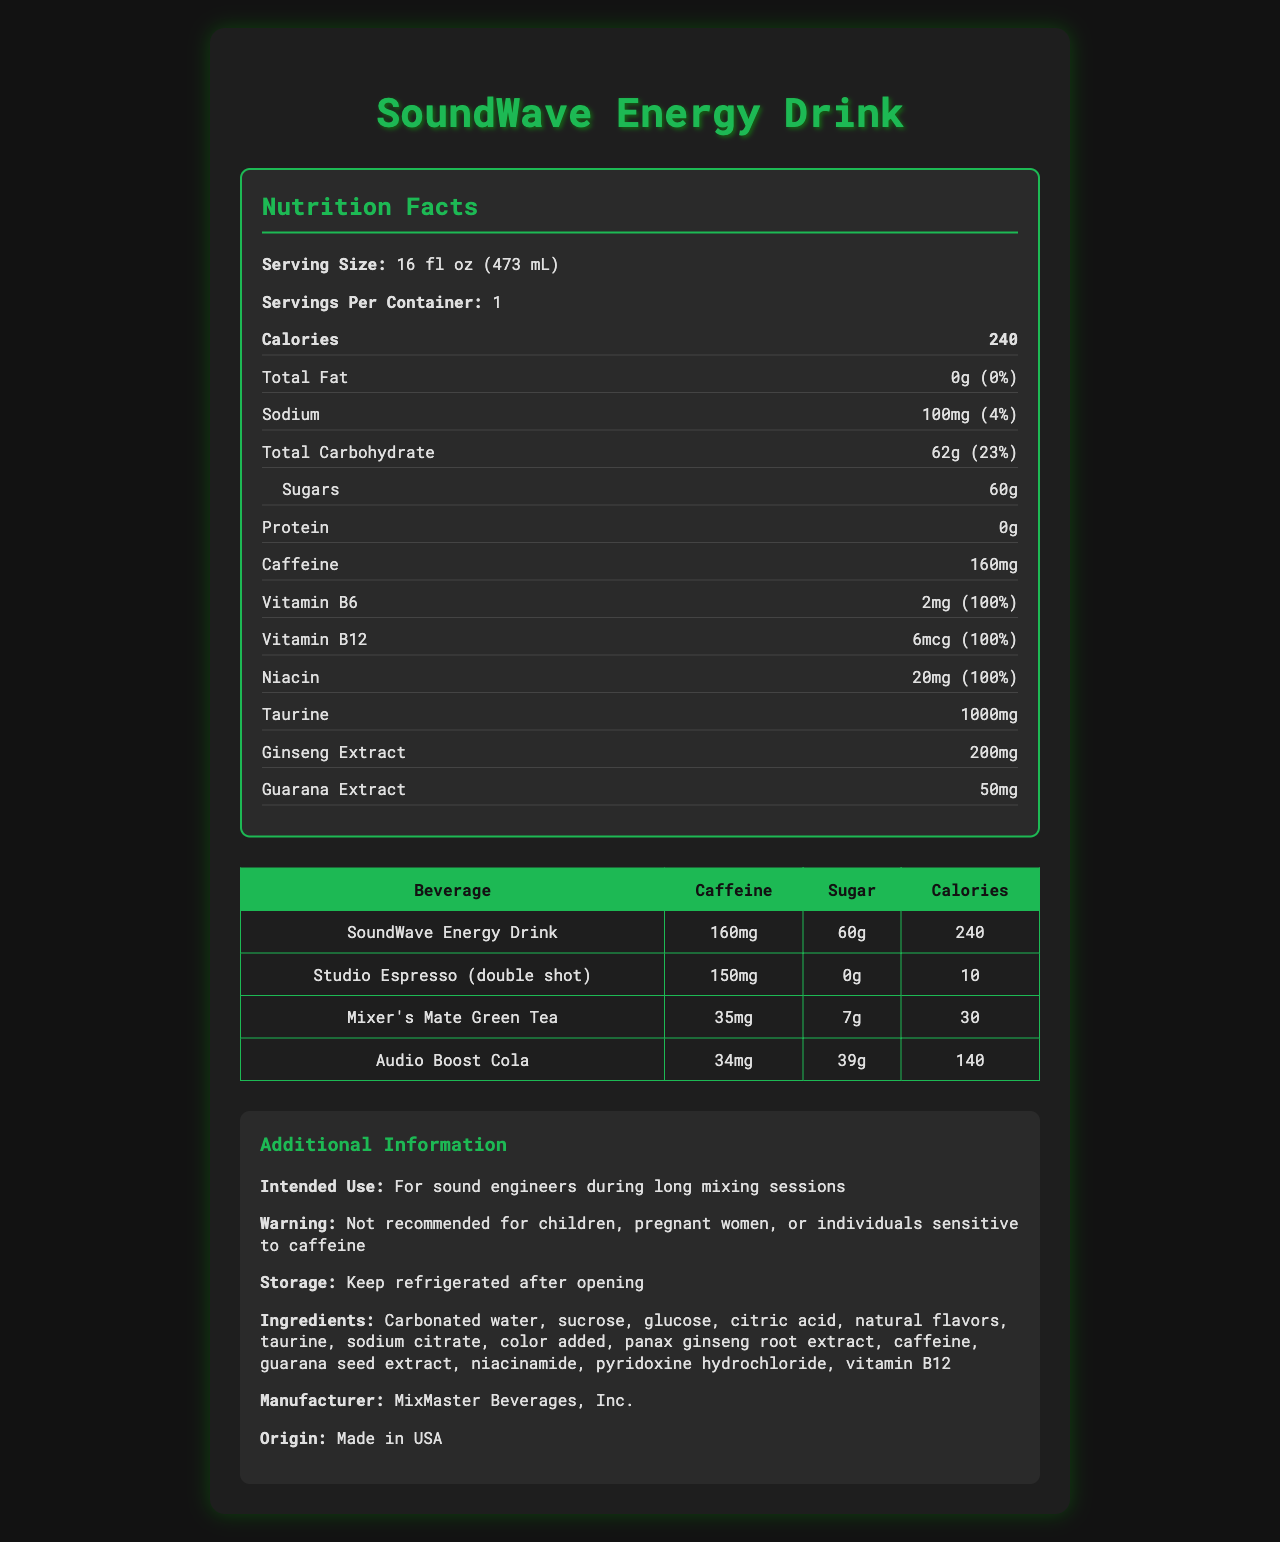what is the serving size of SoundWave Energy Drink? The serving size mentioned at the beginning of the Nutrition Facts section is "16 fl oz (473 mL)."
Answer: 16 fl oz (473 mL) how many calories are in a serving of SoundWave Energy Drink? The document lists the calories under the Nutrition Facts, showing "240" as the calorie amount.
Answer: 240 what is the amount of caffeine in a serving of SoundWave Energy Drink? Under the Nutrition Facts, it specifies the caffeine content as "160mg."
Answer: 160mg what vitamin has 100% daily value in SoundWave Energy Drink? The label lists Vitamin B6 (2mg), Vitamin B12 (6mcg), and Niacin (20mg) all having a daily value of 100%.
Answer: Vitamin B6, Vitamin B12, Niacin how much sodium is in a serving of SoundWave Energy Drink? The Nutrition Facts section shows sodium with an amount of "100mg."
Answer: 100mg which beverage has the highest caffeine content?  
A. SoundWave Energy Drink  
B. Studio Espresso (double shot)  
C. Mixer’s Mate Green Tea  
D. Audio Boost Cola The comparison table lists SoundWave Energy Drink with 160mg of caffeine, higher than the other beverages listed (Studio Espresso with 150mg, Mixer’s Mate Green Tea with 35mg, and Audio Boost Cola with 34mg).
Answer: A. SoundWave Energy Drink which beverage has the lowest calorie count?  
I. SoundWave Energy Drink  
II. Studio Espresso (double shot)  
III. Mixer’s Mate Green Tea  
IV. Audio Boost Cola Studio Espresso (double shot) has the lowest calorie count at 10 calories compared to SoundWave Energy Drink (240), Mixer’s Mate Green Tea (30), and Audio Boost Cola (140).
Answer: II. Studio Espresso (double shot) is there any protein in SoundWave Energy Drink? The Nutrition Facts section lists "0g" for protein, indicating no protein content.
Answer: No summarize the main idea of the document. The document aims to provide comprehensive nutritional and product information for SoundWave Energy Drink, highlighting its suitability for sound engineers during long mixing sessions and comparing its nutrient content with other common caffeinated beverages.
Answer: The document is a detailed Nutrition Facts Label for SoundWave Energy Drink, providing information on its serving size, calorie count, various nutrients, and ingredients. Additionally, it includes a comparison table with other caffeinated beverages and provides additional product information like intended use, warnings, storage instructions, manufacturer, and origin. which beverage has the highest sugar content in the comparison? According to the comparison table, SoundWave Energy Drink has the highest sugar content at 60g compared to the other beverages listed.
Answer: SoundWave Energy Drink how much of Vitamin B6 does SoundWave Energy Drink contain? The Nutrition Facts section shows Vitamin B6 with an amount of "2mg."
Answer: 2mg can children consume SoundWave Energy Drink? The additional information section provides a warning that states it is not recommended for children, pregnant women, or individuals sensitive to caffeine.
Answer: No what is the manufacturer of SoundWave Energy Drink? The additional information section lists the manufacturer as "MixMaster Beverages, Inc."
Answer: MixMaster Beverages, Inc. what flavors are present in SoundWave Energy Drink? The document lists "natural flavors" under the ingredients, but it does not specify what specific flavors are present.
Answer: Cannot be determined 